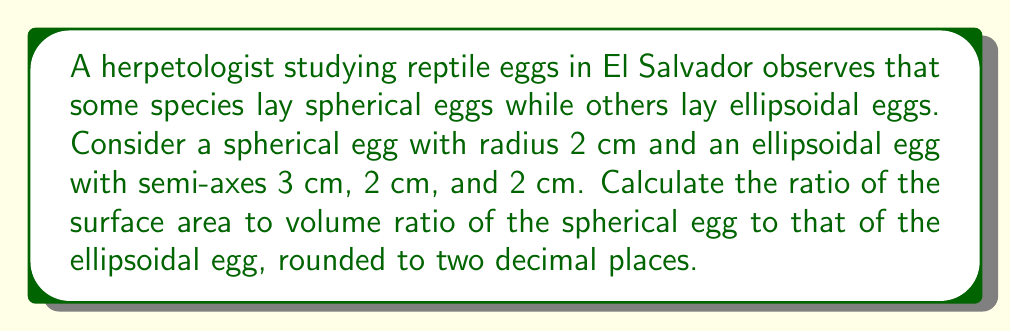What is the answer to this math problem? Let's approach this step-by-step:

1. For the spherical egg:
   - Radius $r = 2$ cm
   - Surface area: $A_s = 4\pi r^2 = 4\pi(2)^2 = 16\pi$ cm²
   - Volume: $V_s = \frac{4}{3}\pi r^3 = \frac{4}{3}\pi(2)^3 = \frac{32\pi}{3}$ cm³
   - Surface area to volume ratio: $R_s = \frac{A_s}{V_s} = \frac{16\pi}{\frac{32\pi}{3}} = \frac{3}{2} = 1.5$ cm⁻¹

2. For the ellipsoidal egg:
   - Semi-axes: $a = 3$ cm, $b = 2$ cm, $c = 2$ cm
   - Surface area (approximation): $A_e \approx 4\pi(\frac{(ab)^{1.6} + (ac)^{1.6} + (bc)^{1.6}}{3})^{\frac{1}{1.6}}$
     $A_e \approx 4\pi(\frac{(3\cdot2)^{1.6} + (3\cdot2)^{1.6} + (2\cdot2)^{1.6}}{3})^{\frac{1}{1.6}} \approx 50.27$ cm²
   - Volume: $V_e = \frac{4}{3}\pi abc = \frac{4}{3}\pi(3)(2)(2) = 16\pi$ cm³
   - Surface area to volume ratio: $R_e = \frac{A_e}{V_e} \approx \frac{50.27}{16\pi} \approx 0.996$ cm⁻¹

3. Ratio of surface area to volume ratios:
   $\frac{R_s}{R_e} = \frac{1.5}{0.996} \approx 1.51$
Answer: 1.51 